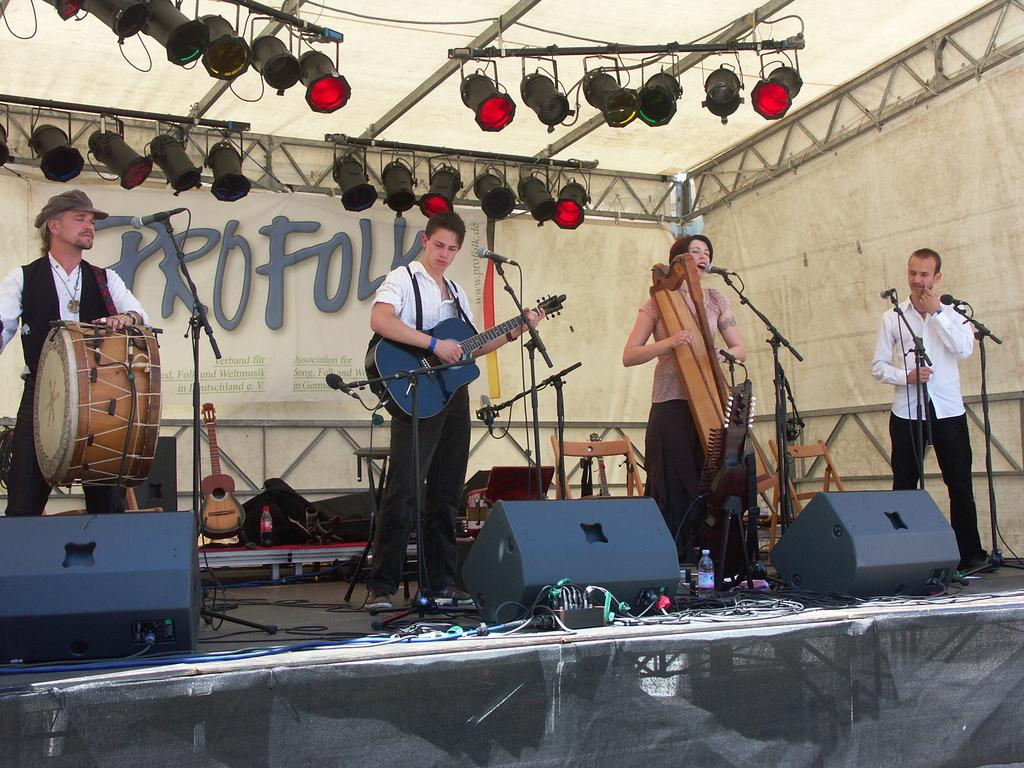How many people are in the image? There are four persons in the image. What are the persons doing in the image? The persons are playing musical instruments. Can you describe the setting in which the persons are playing their instruments? The persons are standing in front of a microphone. Are there any masks visible on the persons in the image? There is no mention of masks in the provided facts, so we cannot determine if any are present in the image. 